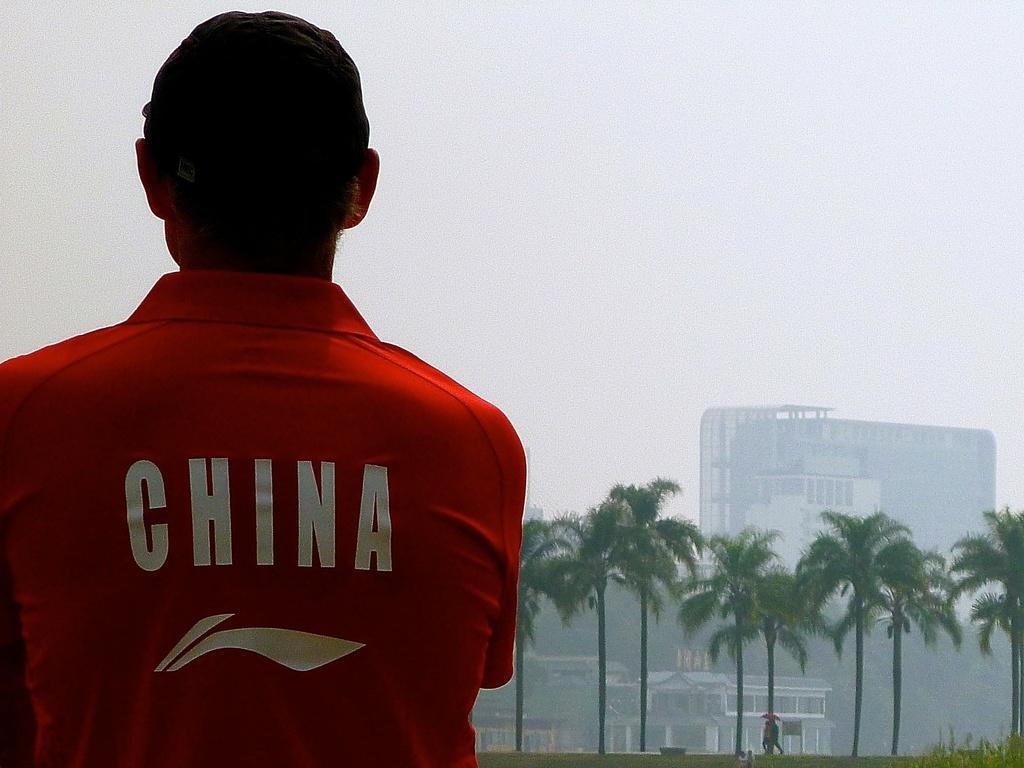What country is this gentleman most likely from?
Your answer should be compact. China. 